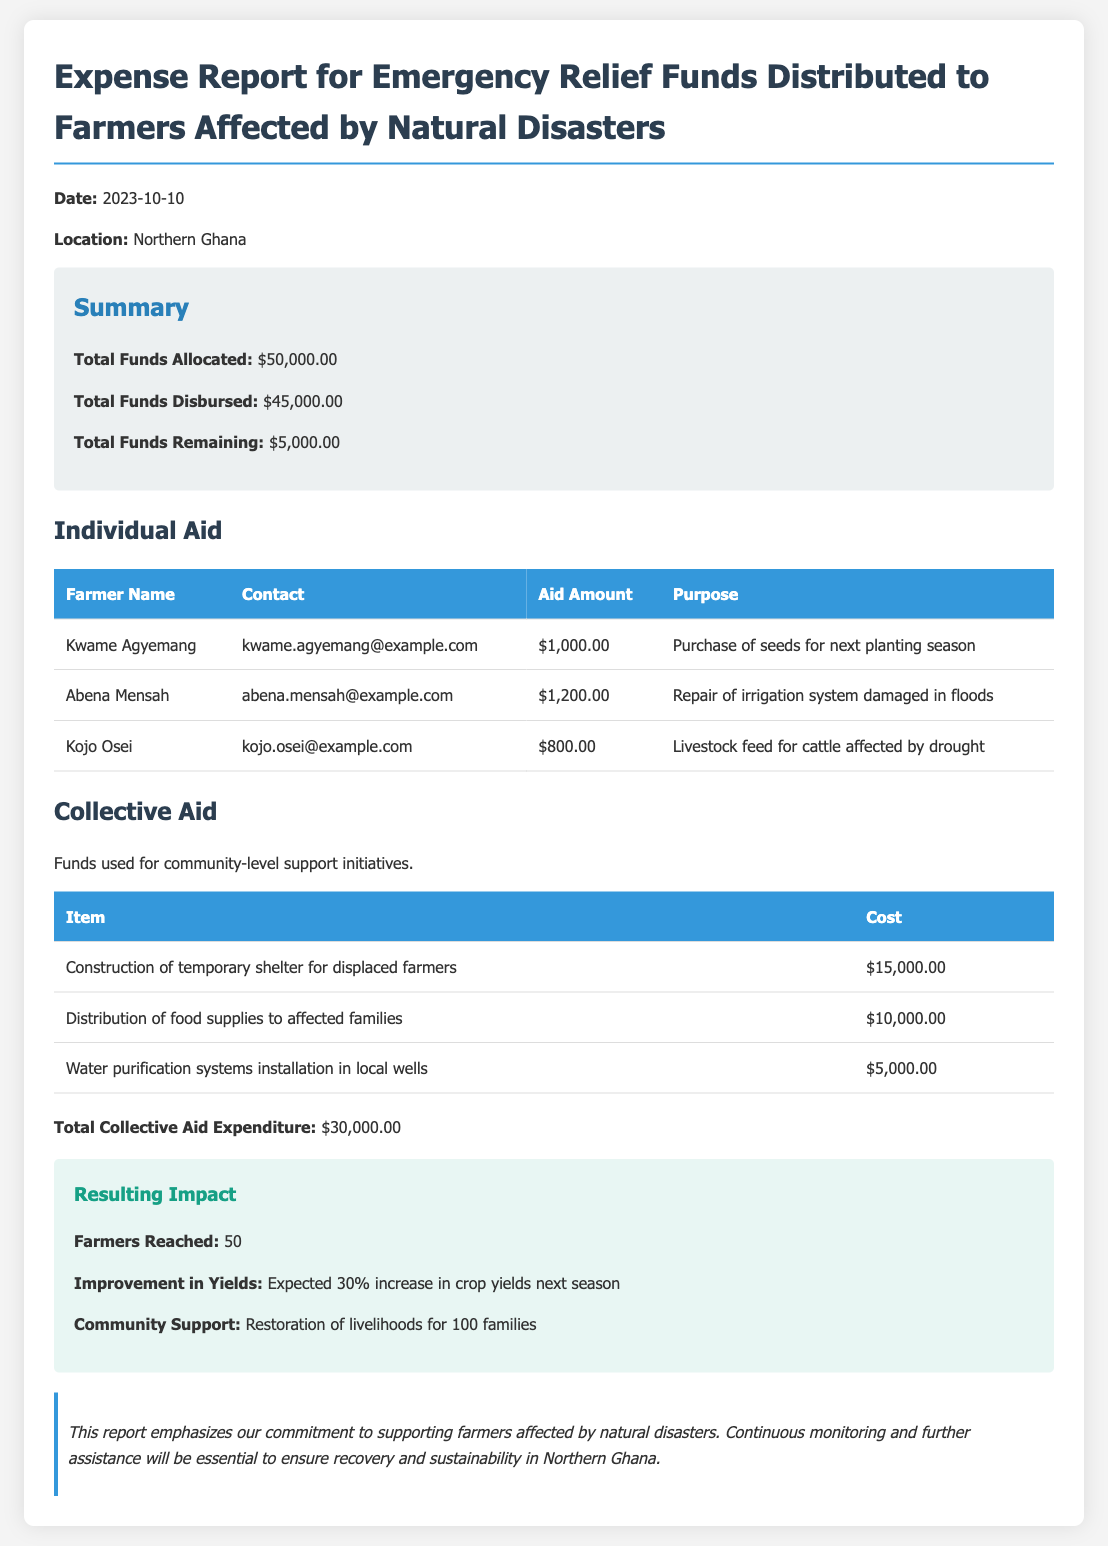What is the total funds allocated? The total funds allocated are explicitly stated in the summary section as $50,000.00.
Answer: $50,000.00 What was the total funds disbursed? The total funds disbursed are provided in the summary section, which states $45,000.00.
Answer: $45,000.00 How much funds remain? The remaining funds are calculated in the summary as the difference between allocated and disbursed funds, noted as $5,000.00.
Answer: $5,000.00 Who received the highest individual aid? The aid amounts are listed, and the highest individual aid of $1,200.00 is attributed to Abena Mensah.
Answer: Abena Mensah What was the cost of water purification systems? The cost for water purification systems is detailed in the collective aid table as $5,000.00.
Answer: $5,000.00 How many farmers were reached? The number of farmers reached is indicated in the impact section as 50.
Answer: 50 What is the expected improvement in crop yields? The document states that a 30% increase in crop yields is expected next season.
Answer: 30% What was the total expenditure for collective aid? The total collective aid expenditure is specifically mentioned as $30,000.00 in the report.
Answer: $30,000.00 What was the purpose of the aid given to Kojo Osei? The purpose for Kojo Osei's aid is stated as livestock feed for cattle affected by drought.
Answer: Livestock feed for cattle affected by drought 